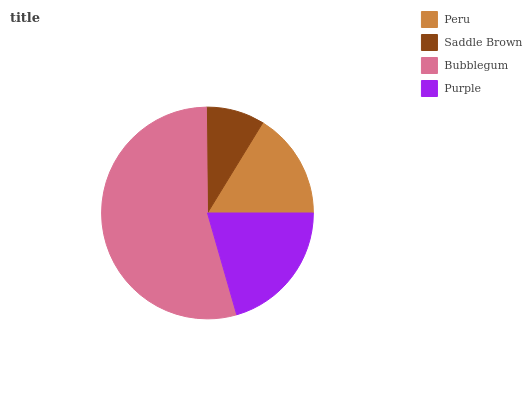Is Saddle Brown the minimum?
Answer yes or no. Yes. Is Bubblegum the maximum?
Answer yes or no. Yes. Is Bubblegum the minimum?
Answer yes or no. No. Is Saddle Brown the maximum?
Answer yes or no. No. Is Bubblegum greater than Saddle Brown?
Answer yes or no. Yes. Is Saddle Brown less than Bubblegum?
Answer yes or no. Yes. Is Saddle Brown greater than Bubblegum?
Answer yes or no. No. Is Bubblegum less than Saddle Brown?
Answer yes or no. No. Is Purple the high median?
Answer yes or no. Yes. Is Peru the low median?
Answer yes or no. Yes. Is Bubblegum the high median?
Answer yes or no. No. Is Bubblegum the low median?
Answer yes or no. No. 